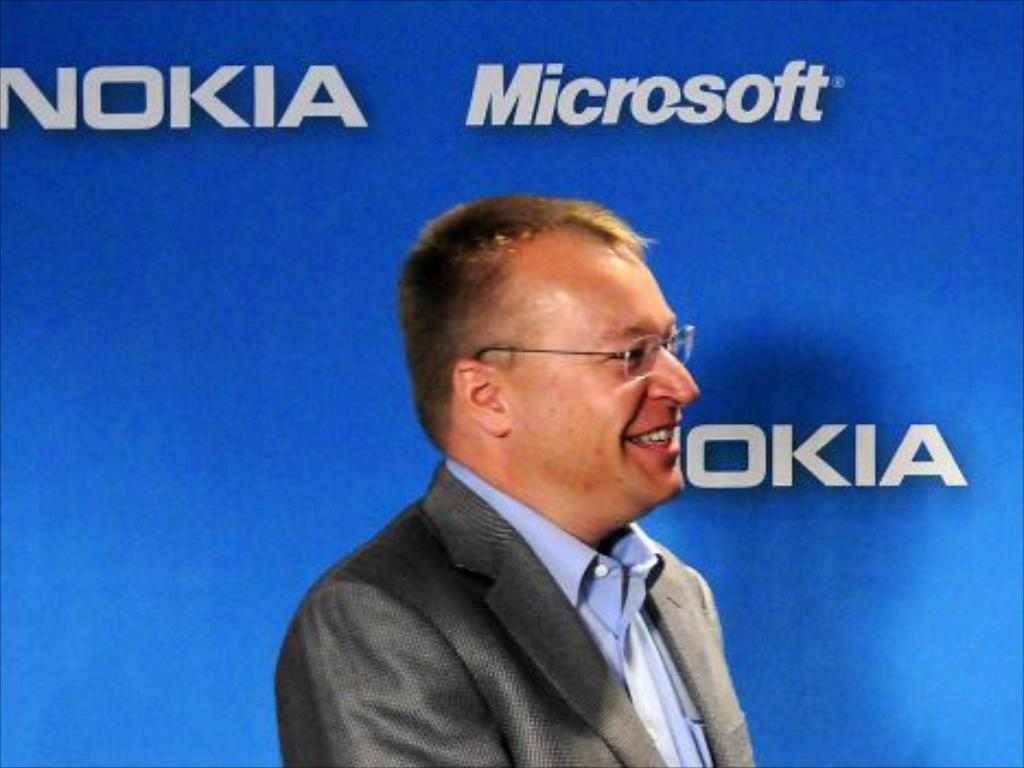<image>
Give a short and clear explanation of the subsequent image. A man in glasses stands in front of a blue wall that says Nokia and Microsoft on it. 